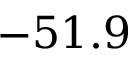Convert formula to latex. <formula><loc_0><loc_0><loc_500><loc_500>- 5 1 . 9</formula> 